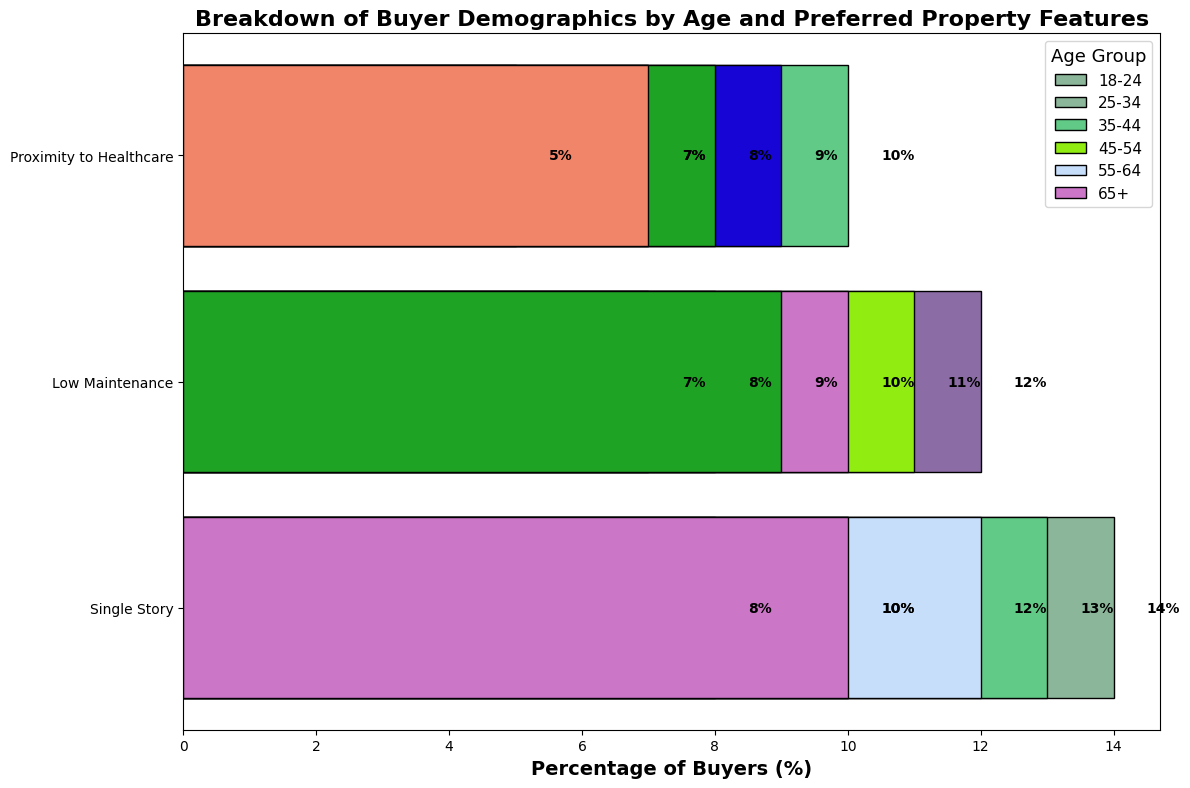What age group shows the highest interest in Modern Design properties? The 25-34 age group has the highest percentage of interest in Modern Design properties with 14%.
Answer: 25-34 Which property feature is most preferred by buyers aged 35-44? Among buyers aged 35-44, Energy Efficiency has the highest percentage at 13%.
Answer: Energy Efficiency What is the total percentage of buyers who prefer Quiet Neighborhood features across all age groups? Summing the percentages for Quiet Neighborhood: 7% (45-54) + 12% (55-64) = 19%.
Answer: 19% Do buyers aged 18-24 prefer Modern Design or Proximity to Public Transport more? Comparing the percentages, Modern Design has 8% and Proximity to Public Transport has 7%; therefore, Modern Design is preferred more.
Answer: Modern Design Which age group has the lowest preference for Large Backyard properties? The 35-44 age group shows a preference of 11%, and the 45-54 age group a preference of 10%. Since there are only these two groups preferring Large Backyard properties, 45-54 has the lowest with 10%.
Answer: 45-54 Is Energy Efficiency more popular among buyers aged 25-34 or 35-44? Energy Efficiency is 10% popular among 25-34 and 13% among 35-44, making it more popular among the 35-44 group.
Answer: 35-44 Which property feature has exactly two age groups expressing a 10% preference? Single Story is preferred by buyers aged 55-64 and 65+ at 10% each.
Answer: Single Story How much higher is the preference for Modern Design among 25-34-year olds compared to 18-24-year olds? The preference is 14% for 25-34 and 8% for 18-24. The difference is 14% - 8% = 6%.
Answer: 6% Which age group represents the largest percentage of buyers interested in Low Maintenance properties? The 55-64 age group has a 10% preference, while 65+ has 9%. Therefore, 55-64 shows the highest interest in Low Maintenance properties.
Answer: 55-64 What is the combined percentage of buyers aged 65+ who prefer Single Story and Proximity to Healthcare features? Summing the percentages for 65+: Single Story is 10% and Proximity to Healthcare is 7%, yielding 10% + 7% = 17%.
Answer: 17% 